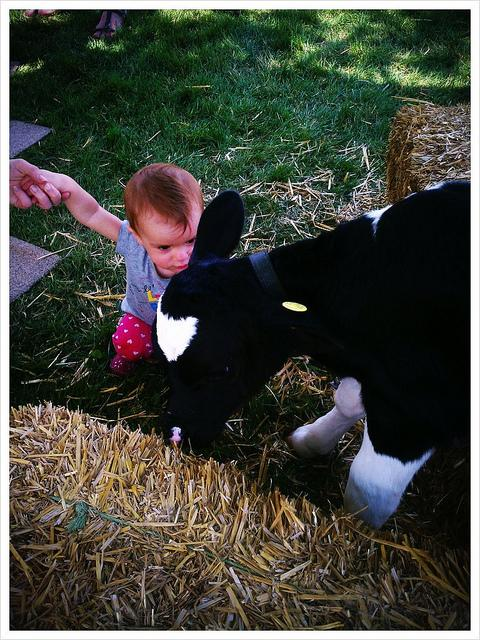What kind of food eater is the animal? Please explain your reasoning. herbivore. Cows eat grass. 